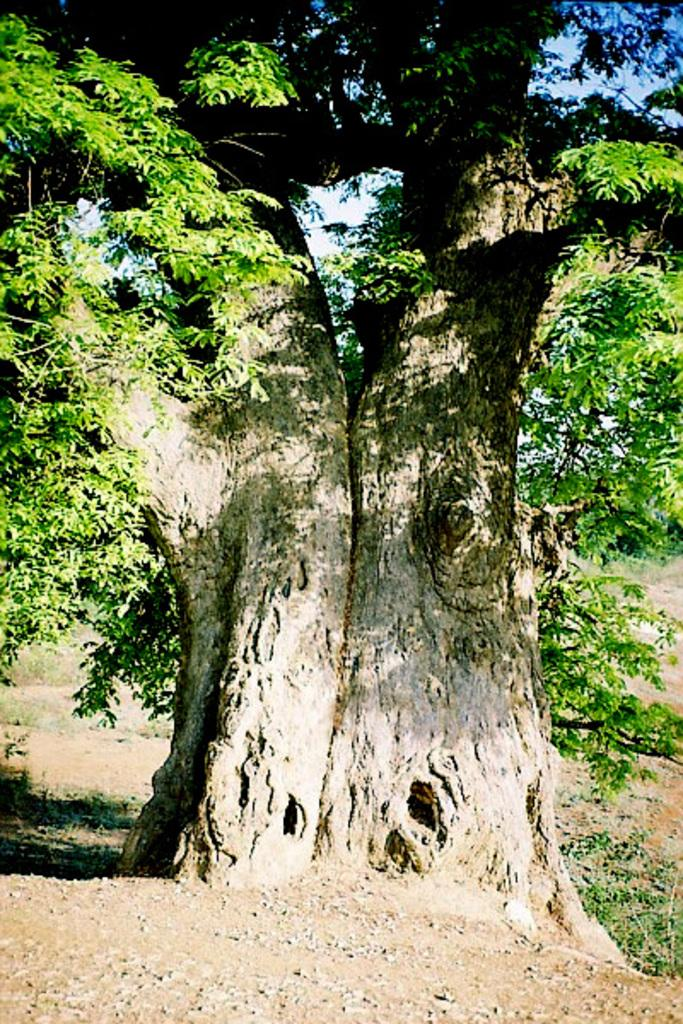What type of vegetation can be seen in the image? There is a tree and plants in the image. What else is present in the image besides vegetation? There are stones in the image. What can be seen in the background of the image? The sky is visible in the image. How many eggs are visible in the image? There are no eggs present in the image. What type of error can be seen in the image? There is no error present in the image. 